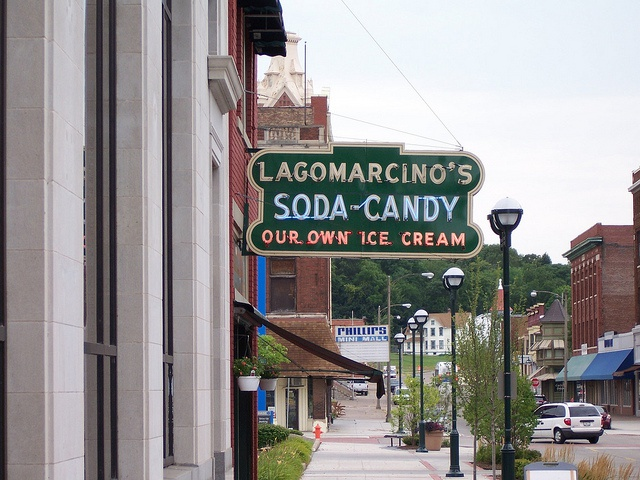Describe the objects in this image and their specific colors. I can see potted plant in black, darkgreen, and gray tones, car in black, lightgray, gray, and darkgray tones, potted plant in black, gray, olive, and darkgray tones, potted plant in black, darkgreen, gray, and olive tones, and potted plant in black, darkgray, gray, and darkgreen tones in this image. 